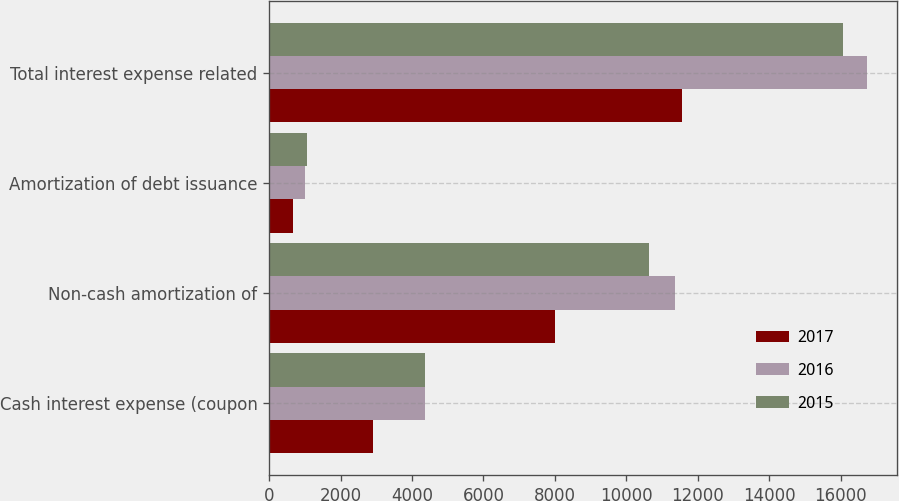<chart> <loc_0><loc_0><loc_500><loc_500><stacked_bar_chart><ecel><fcel>Cash interest expense (coupon<fcel>Non-cash amortization of<fcel>Amortization of debt issuance<fcel>Total interest expense related<nl><fcel>2017<fcel>2898<fcel>8014<fcel>657<fcel>11569<nl><fcel>2016<fcel>4375<fcel>11372<fcel>1005<fcel>16752<nl><fcel>2015<fcel>4375<fcel>10639<fcel>1054<fcel>16068<nl></chart> 